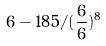<formula> <loc_0><loc_0><loc_500><loc_500>6 - 1 8 5 / ( \frac { 6 } { 6 } ) ^ { 8 }</formula> 